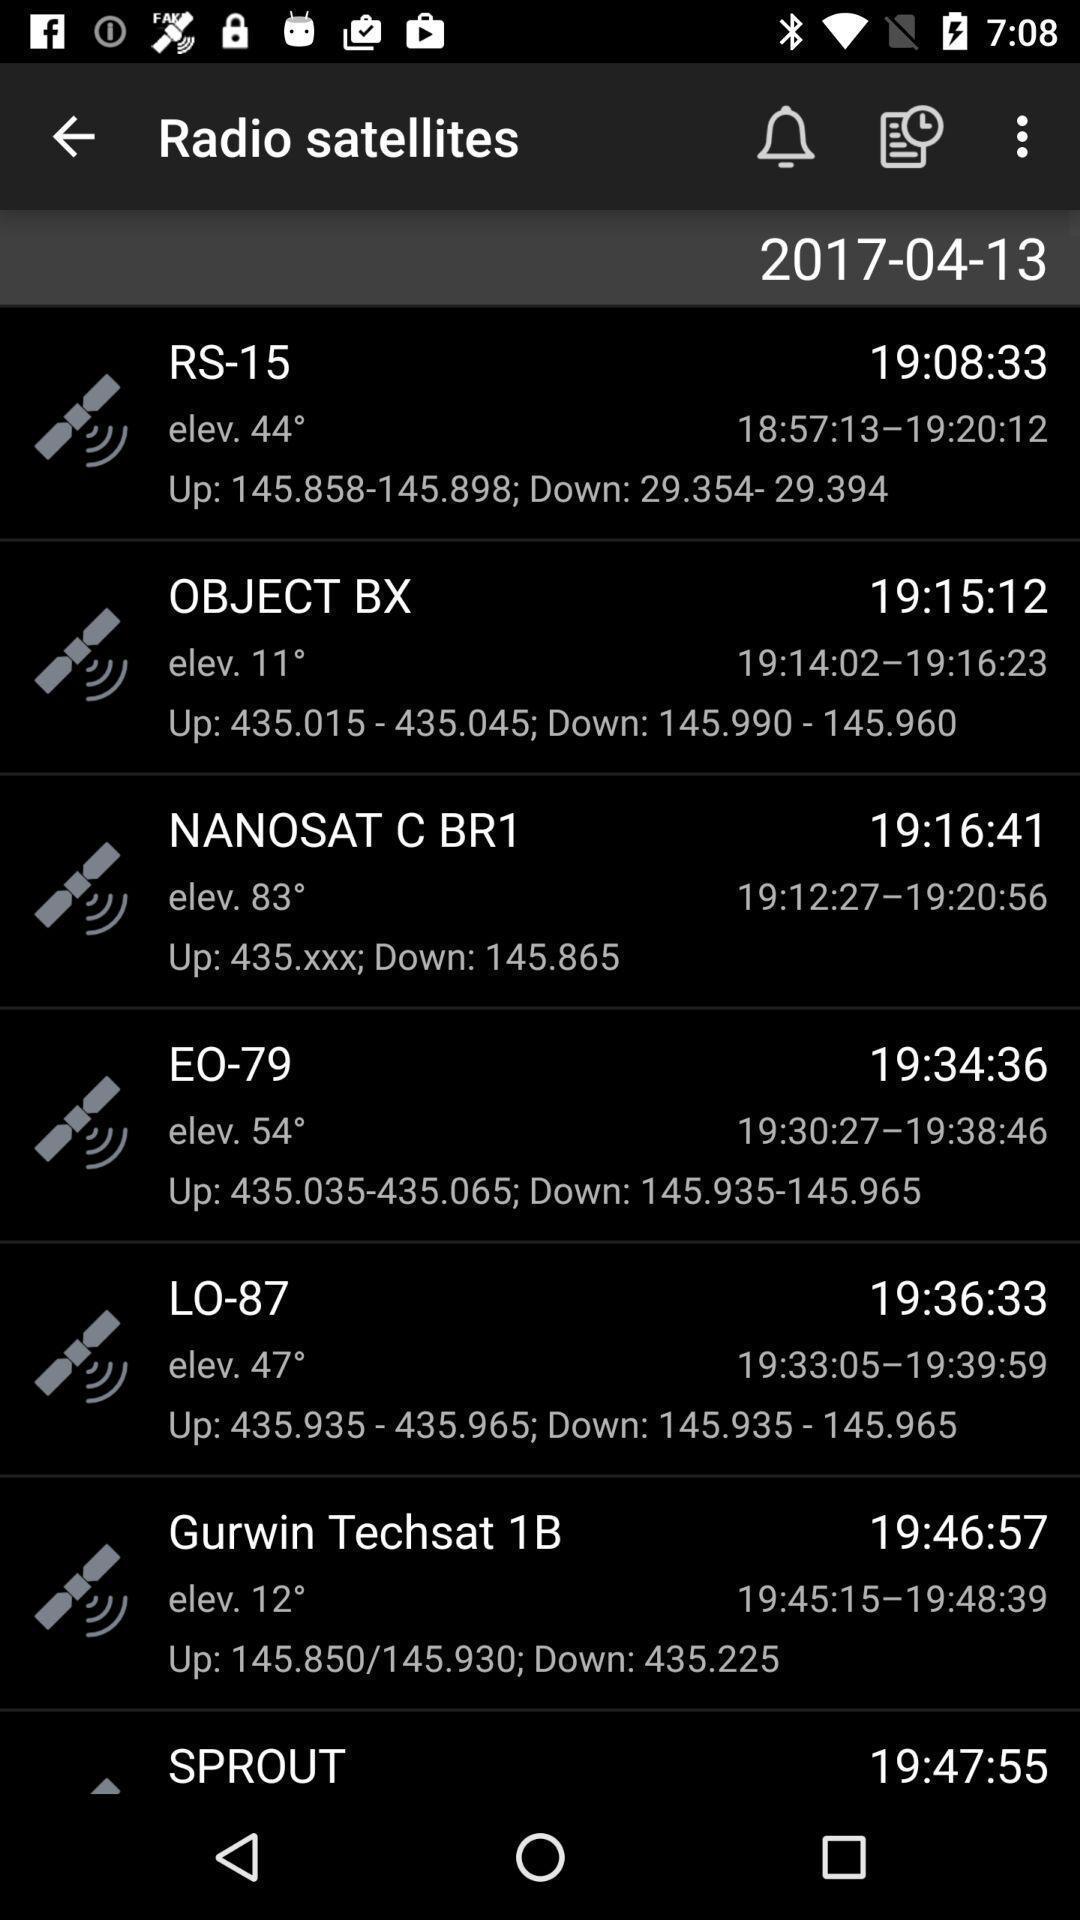Explain what's happening in this screen capture. Page displaying satellites app with multiple sky chart. 